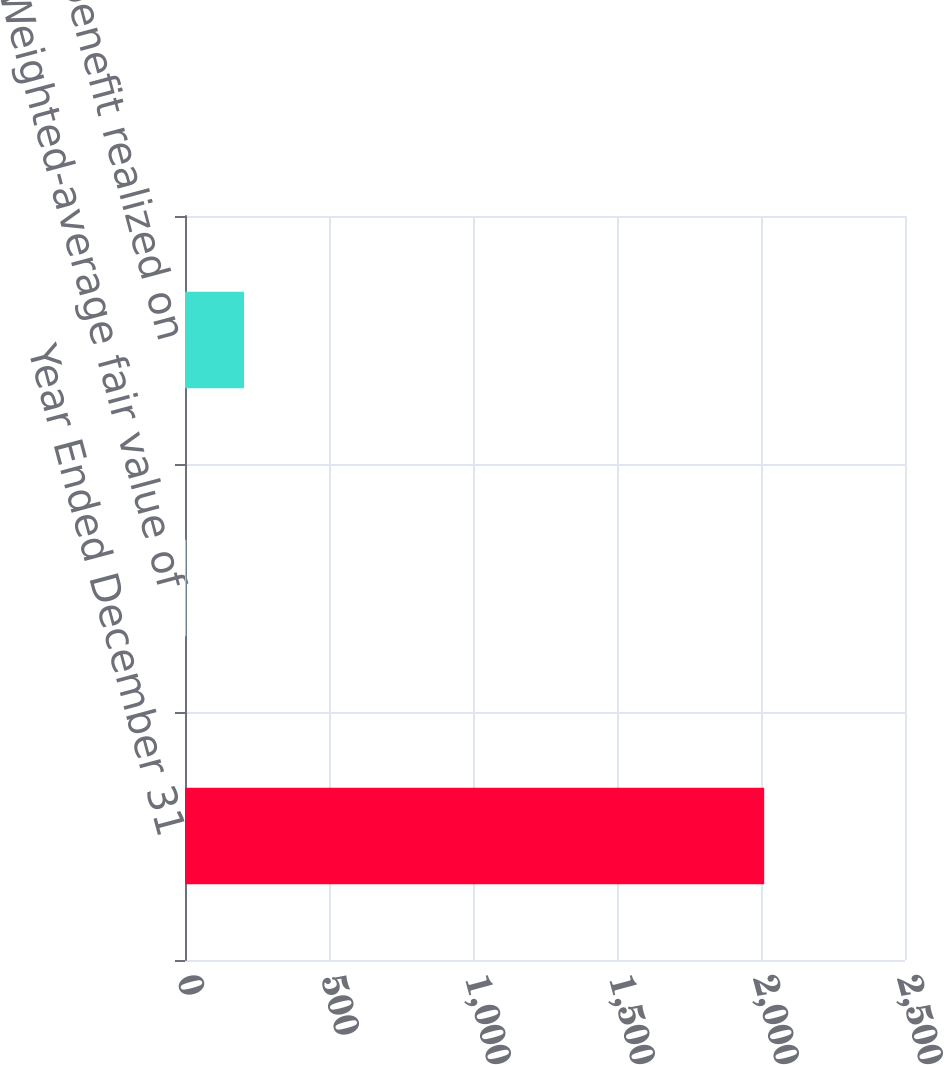Convert chart to OTSL. <chart><loc_0><loc_0><loc_500><loc_500><bar_chart><fcel>Year Ended December 31<fcel>Weighted-average fair value of<fcel>Tax benefit realized on<nl><fcel>2011<fcel>4.16<fcel>204.84<nl></chart> 